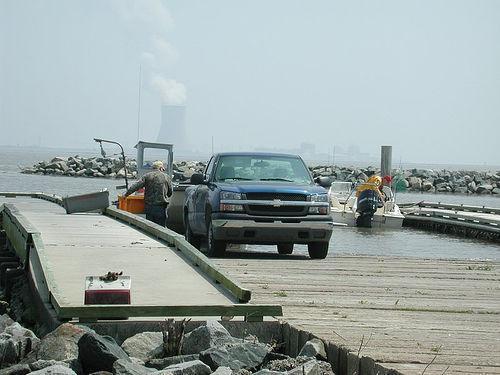How many trucks are there?
Give a very brief answer. 1. 